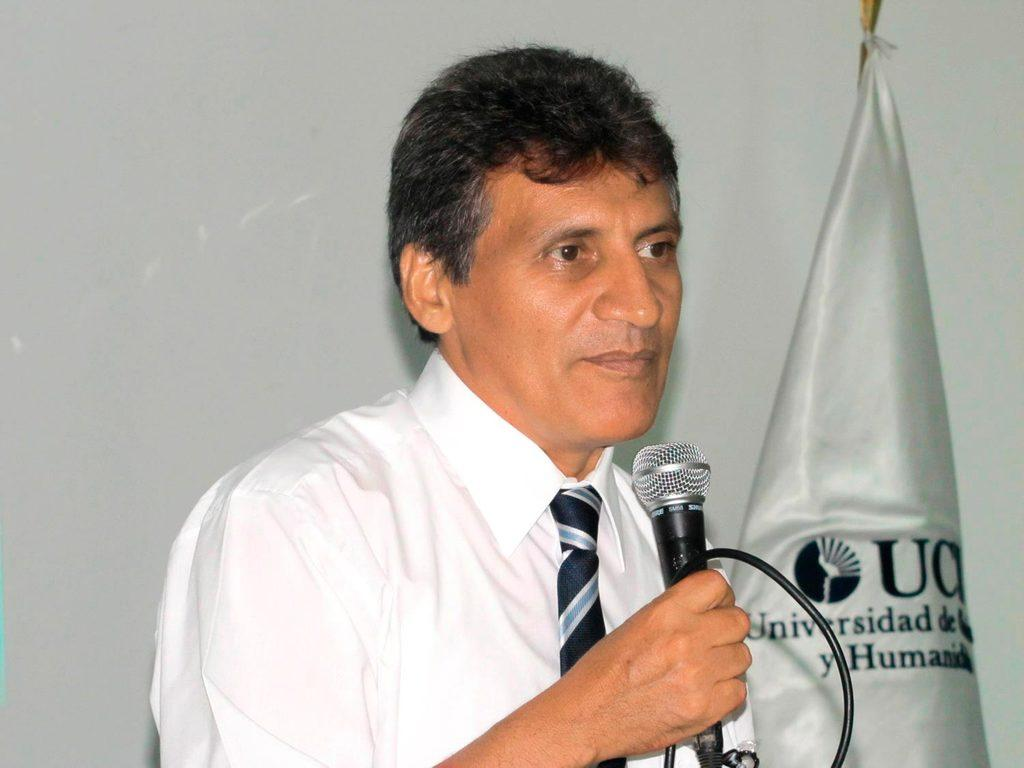Who is present in the image? There is a man in the image. What is the man holding in his hand? The man is holding a microphone in his hand. What can be seen beside the man? There is a flag post beside the man. What type of body of water can be seen in the image? There is: There is no body of water present in the image. 